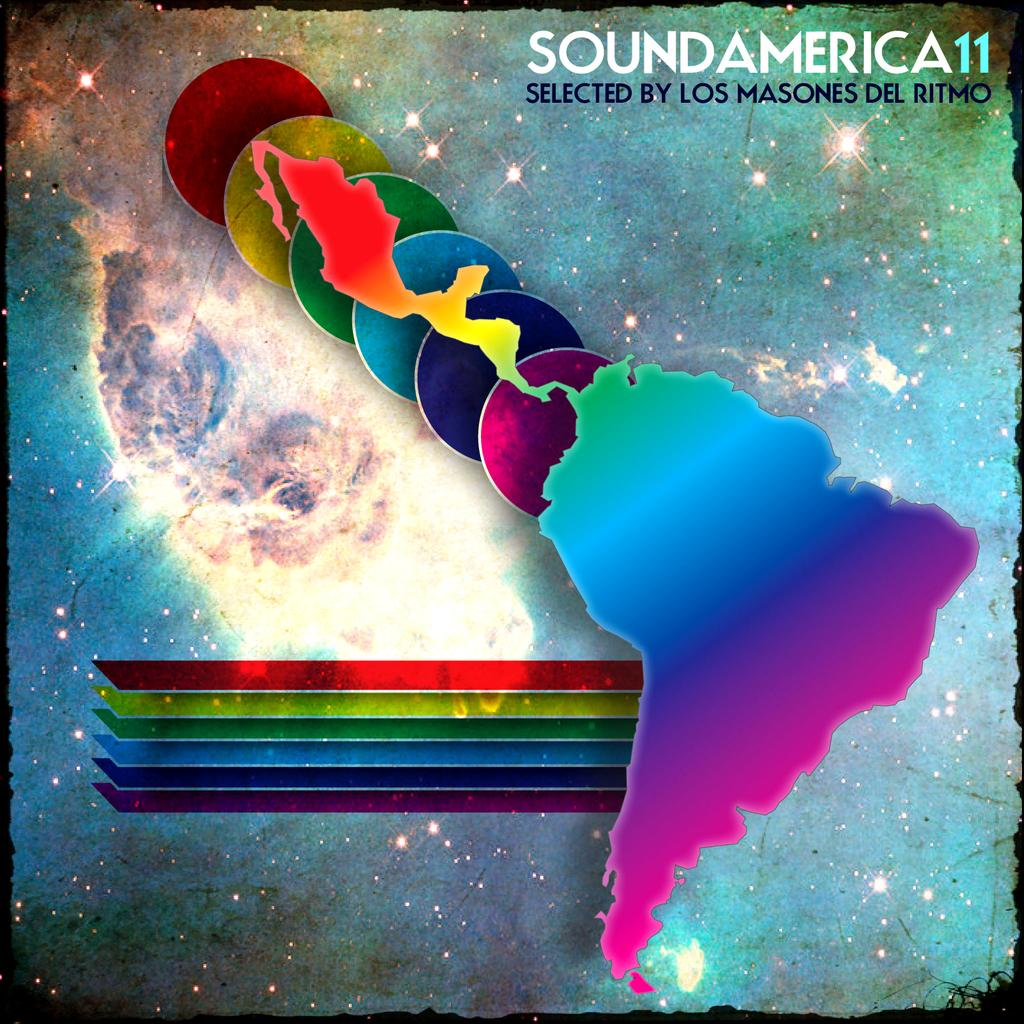<image>
Write a terse but informative summary of the picture. An album cover for the album SoundAmerica 11 